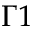<formula> <loc_0><loc_0><loc_500><loc_500>\Gamma 1</formula> 